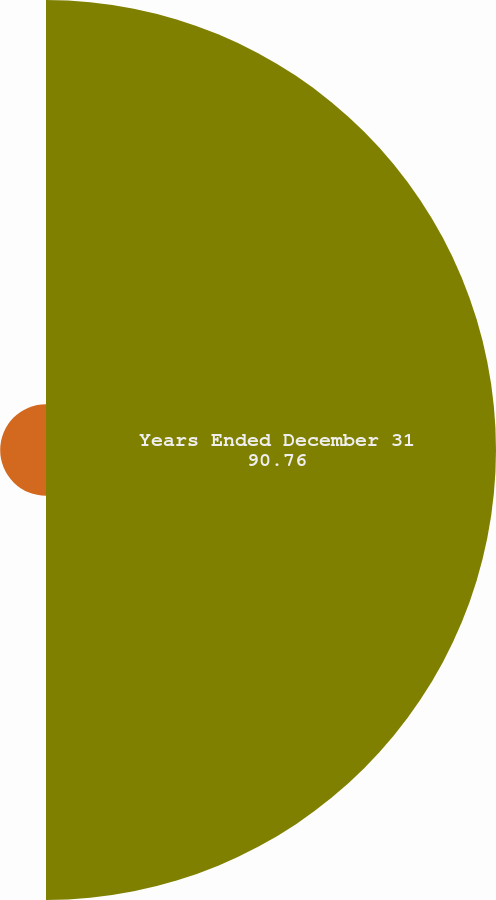Convert chart. <chart><loc_0><loc_0><loc_500><loc_500><pie_chart><fcel>Years Ended December 31<fcel>Allowance for loan losses as a<nl><fcel>90.76%<fcel>9.24%<nl></chart> 